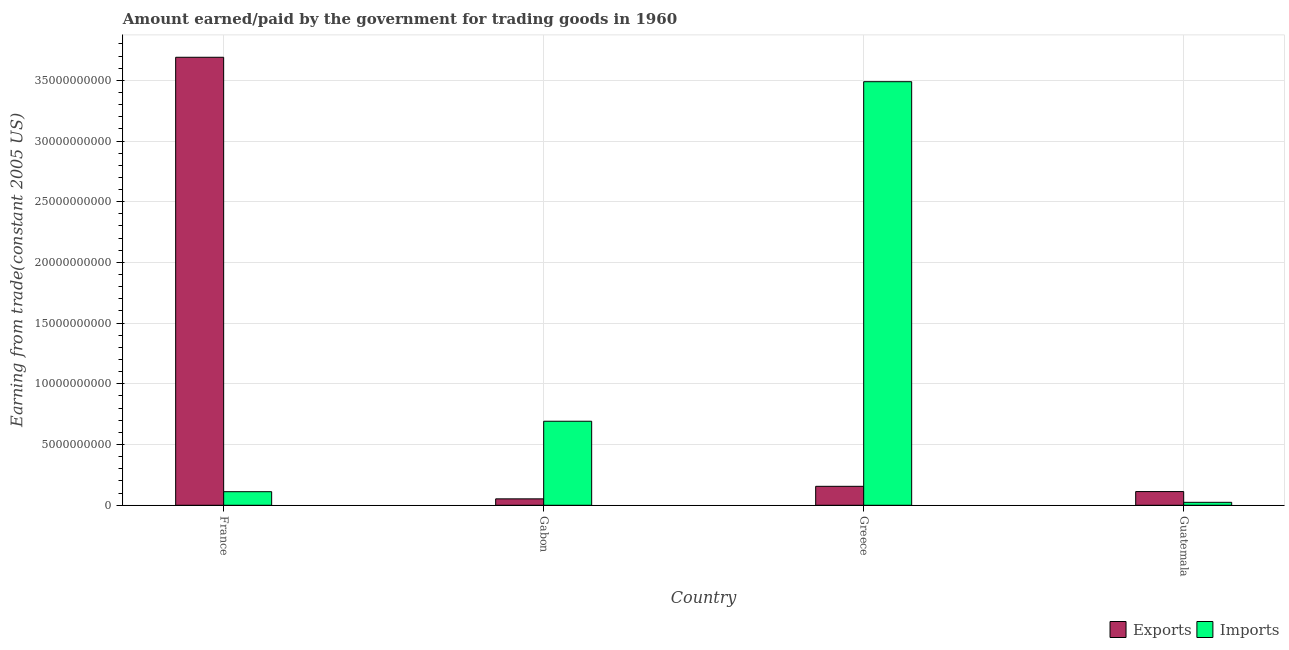How many groups of bars are there?
Your response must be concise. 4. How many bars are there on the 2nd tick from the left?
Offer a very short reply. 2. What is the label of the 4th group of bars from the left?
Make the answer very short. Guatemala. In how many cases, is the number of bars for a given country not equal to the number of legend labels?
Provide a short and direct response. 0. What is the amount paid for imports in Gabon?
Offer a terse response. 6.92e+09. Across all countries, what is the maximum amount paid for imports?
Offer a very short reply. 3.49e+1. Across all countries, what is the minimum amount paid for imports?
Your response must be concise. 2.44e+08. In which country was the amount earned from exports maximum?
Offer a terse response. France. In which country was the amount paid for imports minimum?
Offer a very short reply. Guatemala. What is the total amount paid for imports in the graph?
Provide a succinct answer. 4.32e+1. What is the difference between the amount earned from exports in Greece and that in Guatemala?
Keep it short and to the point. 4.31e+08. What is the difference between the amount paid for imports in Gabon and the amount earned from exports in France?
Provide a short and direct response. -3.00e+1. What is the average amount paid for imports per country?
Your answer should be very brief. 1.08e+1. What is the difference between the amount earned from exports and amount paid for imports in Greece?
Your response must be concise. -3.33e+1. In how many countries, is the amount paid for imports greater than 19000000000 US$?
Offer a very short reply. 1. What is the ratio of the amount earned from exports in Greece to that in Guatemala?
Your answer should be compact. 1.38. Is the amount paid for imports in France less than that in Gabon?
Keep it short and to the point. Yes. Is the difference between the amount earned from exports in Gabon and Guatemala greater than the difference between the amount paid for imports in Gabon and Guatemala?
Keep it short and to the point. No. What is the difference between the highest and the second highest amount earned from exports?
Your answer should be very brief. 3.53e+1. What is the difference between the highest and the lowest amount earned from exports?
Your response must be concise. 3.64e+1. Is the sum of the amount paid for imports in France and Greece greater than the maximum amount earned from exports across all countries?
Offer a very short reply. No. What does the 1st bar from the left in Greece represents?
Keep it short and to the point. Exports. What does the 1st bar from the right in Guatemala represents?
Your answer should be very brief. Imports. How many bars are there?
Provide a short and direct response. 8. Are all the bars in the graph horizontal?
Give a very brief answer. No. What is the difference between two consecutive major ticks on the Y-axis?
Your answer should be very brief. 5.00e+09. Are the values on the major ticks of Y-axis written in scientific E-notation?
Offer a very short reply. No. Where does the legend appear in the graph?
Your answer should be compact. Bottom right. How are the legend labels stacked?
Keep it short and to the point. Horizontal. What is the title of the graph?
Your answer should be compact. Amount earned/paid by the government for trading goods in 1960. Does "Commercial bank branches" appear as one of the legend labels in the graph?
Give a very brief answer. No. What is the label or title of the X-axis?
Offer a terse response. Country. What is the label or title of the Y-axis?
Your response must be concise. Earning from trade(constant 2005 US). What is the Earning from trade(constant 2005 US) of Exports in France?
Make the answer very short. 3.69e+1. What is the Earning from trade(constant 2005 US) of Imports in France?
Offer a very short reply. 1.12e+09. What is the Earning from trade(constant 2005 US) of Exports in Gabon?
Make the answer very short. 5.28e+08. What is the Earning from trade(constant 2005 US) of Imports in Gabon?
Offer a terse response. 6.92e+09. What is the Earning from trade(constant 2005 US) of Exports in Greece?
Your answer should be very brief. 1.56e+09. What is the Earning from trade(constant 2005 US) of Imports in Greece?
Provide a succinct answer. 3.49e+1. What is the Earning from trade(constant 2005 US) of Exports in Guatemala?
Give a very brief answer. 1.13e+09. What is the Earning from trade(constant 2005 US) in Imports in Guatemala?
Provide a succinct answer. 2.44e+08. Across all countries, what is the maximum Earning from trade(constant 2005 US) of Exports?
Offer a very short reply. 3.69e+1. Across all countries, what is the maximum Earning from trade(constant 2005 US) of Imports?
Your response must be concise. 3.49e+1. Across all countries, what is the minimum Earning from trade(constant 2005 US) of Exports?
Provide a succinct answer. 5.28e+08. Across all countries, what is the minimum Earning from trade(constant 2005 US) in Imports?
Your answer should be compact. 2.44e+08. What is the total Earning from trade(constant 2005 US) in Exports in the graph?
Keep it short and to the point. 4.01e+1. What is the total Earning from trade(constant 2005 US) in Imports in the graph?
Offer a terse response. 4.32e+1. What is the difference between the Earning from trade(constant 2005 US) in Exports in France and that in Gabon?
Ensure brevity in your answer.  3.64e+1. What is the difference between the Earning from trade(constant 2005 US) of Imports in France and that in Gabon?
Ensure brevity in your answer.  -5.80e+09. What is the difference between the Earning from trade(constant 2005 US) of Exports in France and that in Greece?
Ensure brevity in your answer.  3.53e+1. What is the difference between the Earning from trade(constant 2005 US) in Imports in France and that in Greece?
Your answer should be very brief. -3.38e+1. What is the difference between the Earning from trade(constant 2005 US) of Exports in France and that in Guatemala?
Your response must be concise. 3.58e+1. What is the difference between the Earning from trade(constant 2005 US) of Imports in France and that in Guatemala?
Ensure brevity in your answer.  8.74e+08. What is the difference between the Earning from trade(constant 2005 US) of Exports in Gabon and that in Greece?
Provide a succinct answer. -1.03e+09. What is the difference between the Earning from trade(constant 2005 US) in Imports in Gabon and that in Greece?
Provide a succinct answer. -2.80e+1. What is the difference between the Earning from trade(constant 2005 US) of Exports in Gabon and that in Guatemala?
Ensure brevity in your answer.  -6.01e+08. What is the difference between the Earning from trade(constant 2005 US) in Imports in Gabon and that in Guatemala?
Provide a short and direct response. 6.68e+09. What is the difference between the Earning from trade(constant 2005 US) of Exports in Greece and that in Guatemala?
Give a very brief answer. 4.31e+08. What is the difference between the Earning from trade(constant 2005 US) in Imports in Greece and that in Guatemala?
Keep it short and to the point. 3.46e+1. What is the difference between the Earning from trade(constant 2005 US) in Exports in France and the Earning from trade(constant 2005 US) in Imports in Gabon?
Offer a terse response. 3.00e+1. What is the difference between the Earning from trade(constant 2005 US) in Exports in France and the Earning from trade(constant 2005 US) in Imports in Greece?
Offer a terse response. 2.01e+09. What is the difference between the Earning from trade(constant 2005 US) of Exports in France and the Earning from trade(constant 2005 US) of Imports in Guatemala?
Offer a terse response. 3.67e+1. What is the difference between the Earning from trade(constant 2005 US) of Exports in Gabon and the Earning from trade(constant 2005 US) of Imports in Greece?
Make the answer very short. -3.44e+1. What is the difference between the Earning from trade(constant 2005 US) in Exports in Gabon and the Earning from trade(constant 2005 US) in Imports in Guatemala?
Your answer should be compact. 2.85e+08. What is the difference between the Earning from trade(constant 2005 US) in Exports in Greece and the Earning from trade(constant 2005 US) in Imports in Guatemala?
Offer a very short reply. 1.32e+09. What is the average Earning from trade(constant 2005 US) in Exports per country?
Offer a terse response. 1.00e+1. What is the average Earning from trade(constant 2005 US) of Imports per country?
Provide a short and direct response. 1.08e+1. What is the difference between the Earning from trade(constant 2005 US) in Exports and Earning from trade(constant 2005 US) in Imports in France?
Give a very brief answer. 3.58e+1. What is the difference between the Earning from trade(constant 2005 US) in Exports and Earning from trade(constant 2005 US) in Imports in Gabon?
Provide a succinct answer. -6.39e+09. What is the difference between the Earning from trade(constant 2005 US) in Exports and Earning from trade(constant 2005 US) in Imports in Greece?
Give a very brief answer. -3.33e+1. What is the difference between the Earning from trade(constant 2005 US) of Exports and Earning from trade(constant 2005 US) of Imports in Guatemala?
Ensure brevity in your answer.  8.85e+08. What is the ratio of the Earning from trade(constant 2005 US) of Exports in France to that in Gabon?
Keep it short and to the point. 69.83. What is the ratio of the Earning from trade(constant 2005 US) in Imports in France to that in Gabon?
Your answer should be compact. 0.16. What is the ratio of the Earning from trade(constant 2005 US) of Exports in France to that in Greece?
Provide a short and direct response. 23.64. What is the ratio of the Earning from trade(constant 2005 US) of Imports in France to that in Greece?
Give a very brief answer. 0.03. What is the ratio of the Earning from trade(constant 2005 US) in Exports in France to that in Guatemala?
Your answer should be compact. 32.67. What is the ratio of the Earning from trade(constant 2005 US) of Imports in France to that in Guatemala?
Offer a very short reply. 4.59. What is the ratio of the Earning from trade(constant 2005 US) in Exports in Gabon to that in Greece?
Offer a terse response. 0.34. What is the ratio of the Earning from trade(constant 2005 US) in Imports in Gabon to that in Greece?
Your answer should be very brief. 0.2. What is the ratio of the Earning from trade(constant 2005 US) in Exports in Gabon to that in Guatemala?
Offer a terse response. 0.47. What is the ratio of the Earning from trade(constant 2005 US) of Imports in Gabon to that in Guatemala?
Your answer should be very brief. 28.38. What is the ratio of the Earning from trade(constant 2005 US) in Exports in Greece to that in Guatemala?
Ensure brevity in your answer.  1.38. What is the ratio of the Earning from trade(constant 2005 US) of Imports in Greece to that in Guatemala?
Your answer should be compact. 143.08. What is the difference between the highest and the second highest Earning from trade(constant 2005 US) in Exports?
Your answer should be very brief. 3.53e+1. What is the difference between the highest and the second highest Earning from trade(constant 2005 US) in Imports?
Provide a short and direct response. 2.80e+1. What is the difference between the highest and the lowest Earning from trade(constant 2005 US) of Exports?
Ensure brevity in your answer.  3.64e+1. What is the difference between the highest and the lowest Earning from trade(constant 2005 US) of Imports?
Your response must be concise. 3.46e+1. 